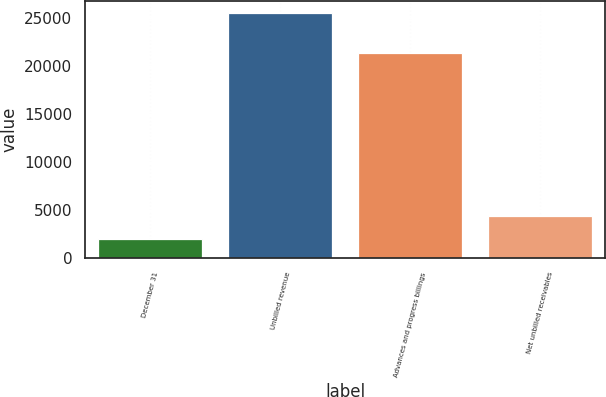<chart> <loc_0><loc_0><loc_500><loc_500><bar_chart><fcel>December 31<fcel>Unbilled revenue<fcel>Advances and progress billings<fcel>Net unbilled receivables<nl><fcel>2016<fcel>25543<fcel>21331<fcel>4368.7<nl></chart> 